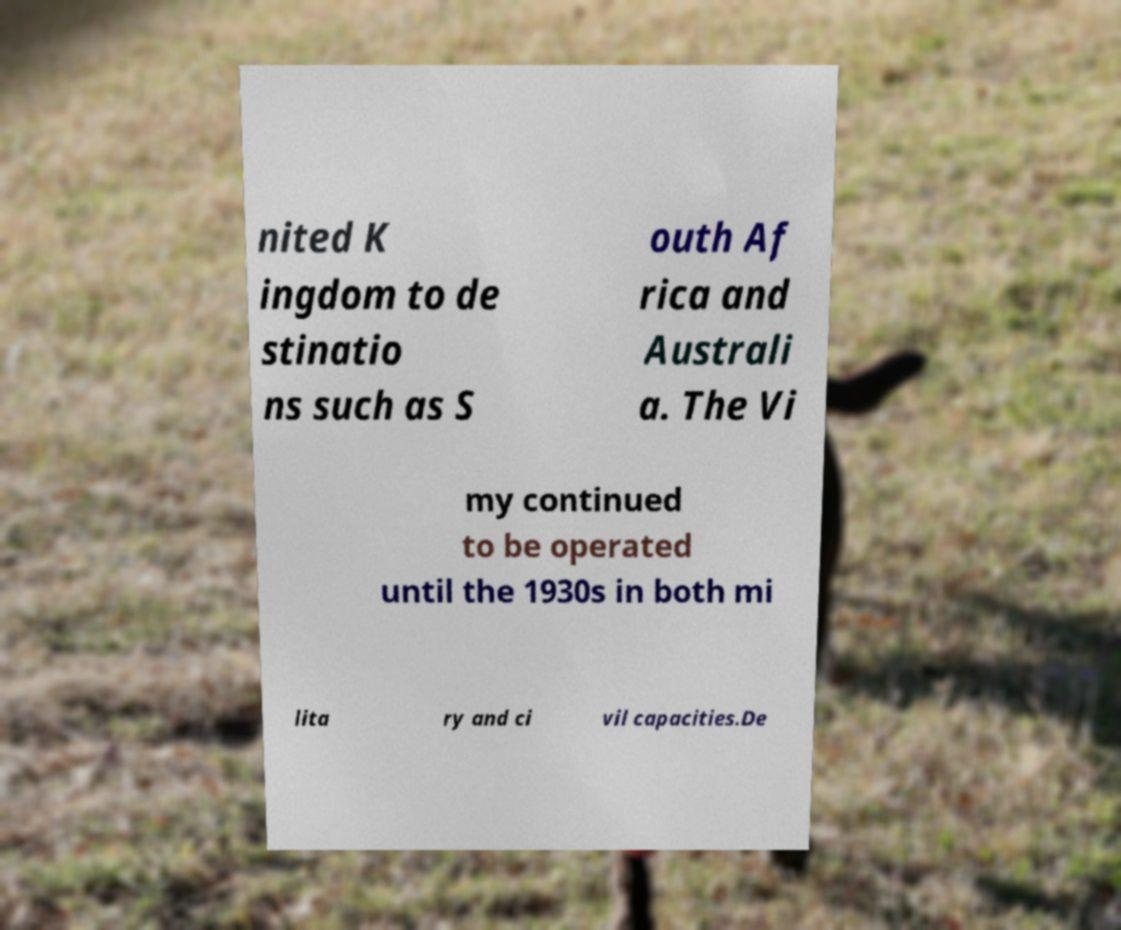Please identify and transcribe the text found in this image. nited K ingdom to de stinatio ns such as S outh Af rica and Australi a. The Vi my continued to be operated until the 1930s in both mi lita ry and ci vil capacities.De 